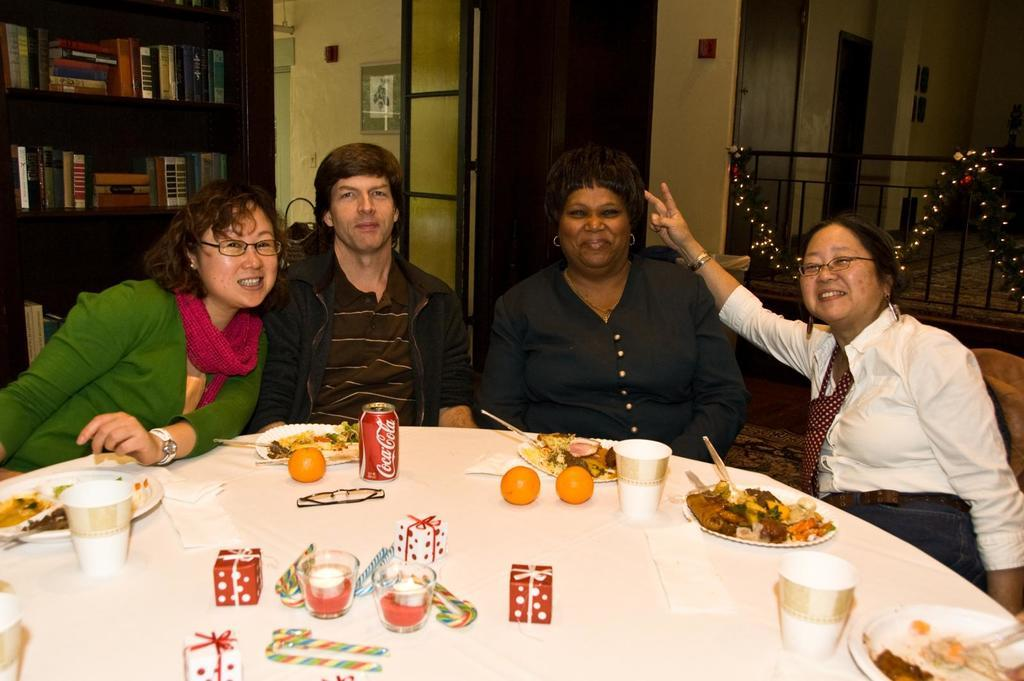What are the people in the image doing? The people in the image are sitting on chairs. What can be found on the table in the image? There are plates, food, cups, fruits, a tin, a spectacle, boxes, and glasses on the table. What is visible in the background of the image? There is a wall, a door, and shelves with books in the background. Can you tell me how many kitties are teaching the people in the image? There are no kitties present in the image, and no teaching is taking place. 